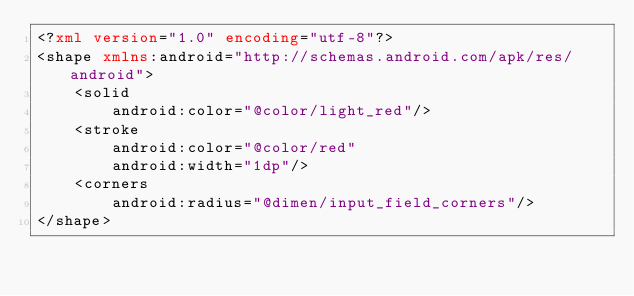<code> <loc_0><loc_0><loc_500><loc_500><_XML_><?xml version="1.0" encoding="utf-8"?>
<shape xmlns:android="http://schemas.android.com/apk/res/android">
    <solid
        android:color="@color/light_red"/>
    <stroke
        android:color="@color/red"
        android:width="1dp"/>
    <corners
        android:radius="@dimen/input_field_corners"/>
</shape></code> 